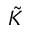Convert formula to latex. <formula><loc_0><loc_0><loc_500><loc_500>\tilde { K }</formula> 